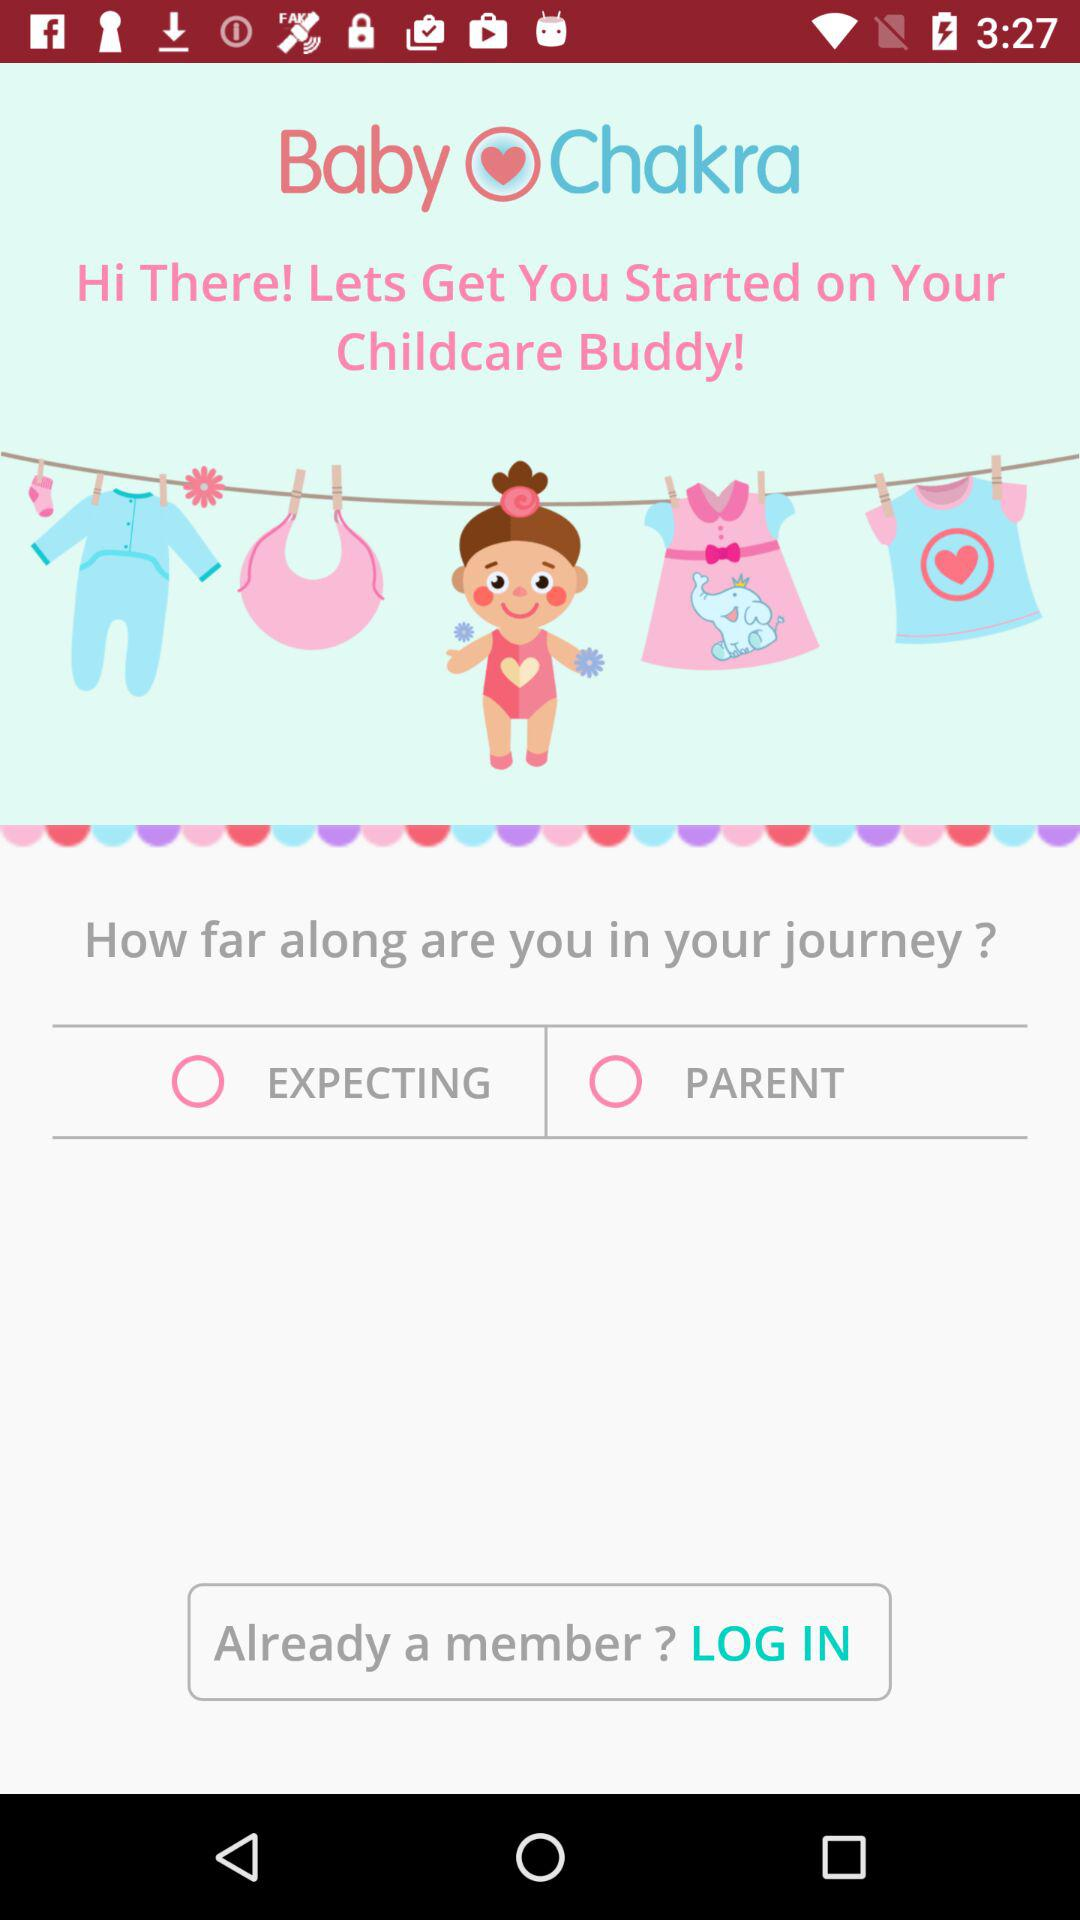What is the name of the application? The name of the application is "Baby Chakra". 